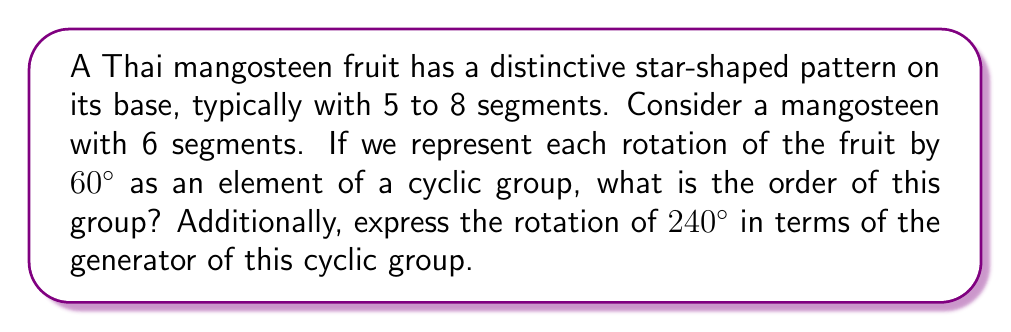Help me with this question. Let's approach this step-by-step:

1) First, we need to understand what a cyclic group is in this context. A cyclic group is a group that can be generated by a single element, called the generator.

2) In this case, our generator is a rotation of $60^\circ$. Let's call this generator $a$.

3) The order of a cyclic group is the number of distinct elements in the group. To find this, we need to determine how many times we need to apply the generator to get back to the identity element (a full $360^\circ$ rotation).

4) We can express this mathematically:
   $$360^\circ = 60^\circ \cdot n$$
   where $n$ is the order of the group.

5) Solving for $n$:
   $$n = 360^\circ / 60^\circ = 6$$

6) Therefore, the cyclic group has order 6. We can denote this group as $C_6$ or $\mathbb{Z}_6$.

7) Now, for the second part of the question, we need to express a $240^\circ$ rotation in terms of the generator $a$.

8) We can think of this as:
   $$240^\circ = 60^\circ \cdot m$$
   where $m$ is the number of times we apply the generator.

9) Solving for $m$:
   $$m = 240^\circ / 60^\circ = 4$$

10) Therefore, a $240^\circ$ rotation is equivalent to applying the generator 4 times, which we can write as $a^4$ in group theory notation.
Answer: The order of the cyclic group is 6. The rotation of $240^\circ$ can be expressed as $a^4$, where $a$ is the generator of the cyclic group (a $60^\circ$ rotation). 